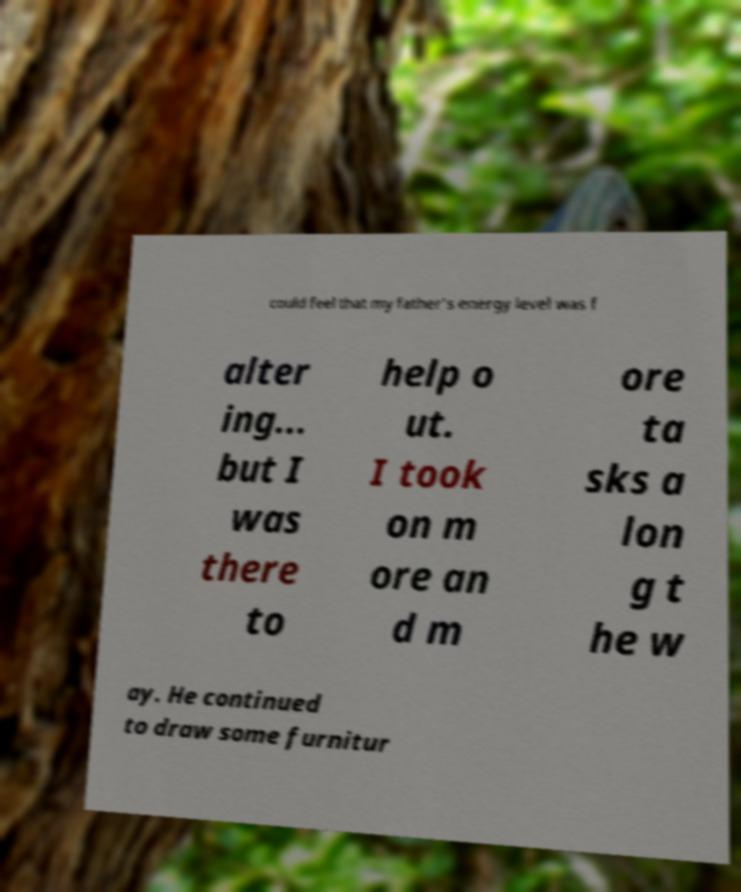Could you assist in decoding the text presented in this image and type it out clearly? could feel that my father's energy level was f alter ing... but I was there to help o ut. I took on m ore an d m ore ta sks a lon g t he w ay. He continued to draw some furnitur 